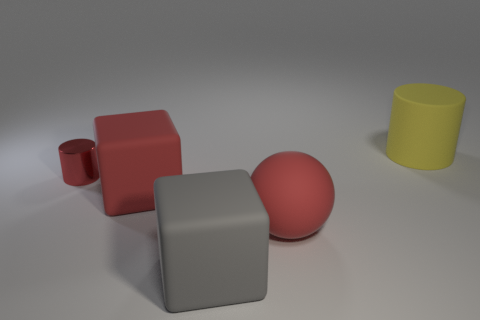Add 1 big red matte cylinders. How many objects exist? 6 Subtract all cylinders. How many objects are left? 3 Add 2 shiny things. How many shiny things are left? 3 Add 5 matte spheres. How many matte spheres exist? 6 Subtract 0 purple spheres. How many objects are left? 5 Subtract all small shiny things. Subtract all rubber cylinders. How many objects are left? 3 